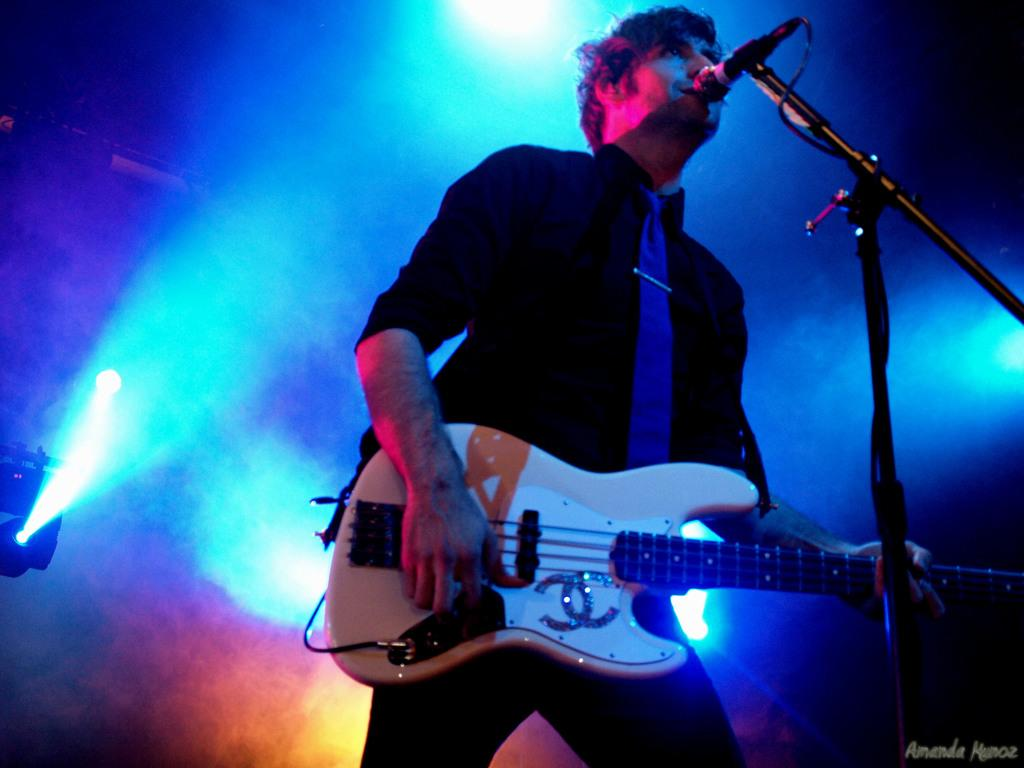What is the person in the image doing? The person is standing in front of a mic and holding a guitar. What is the person wearing? The person is wearing a black shirt and a tie. What can be seen in the background of the image? There are lights and smoke in the background of the image. What type of breakfast is the person eating in the image? There is no breakfast present in the image; the person is holding a guitar and standing in front of a mic. What color is the sweater the person is wearing in the image? The person is not wearing a sweater in the image; they are wearing a black shirt and a tie. 